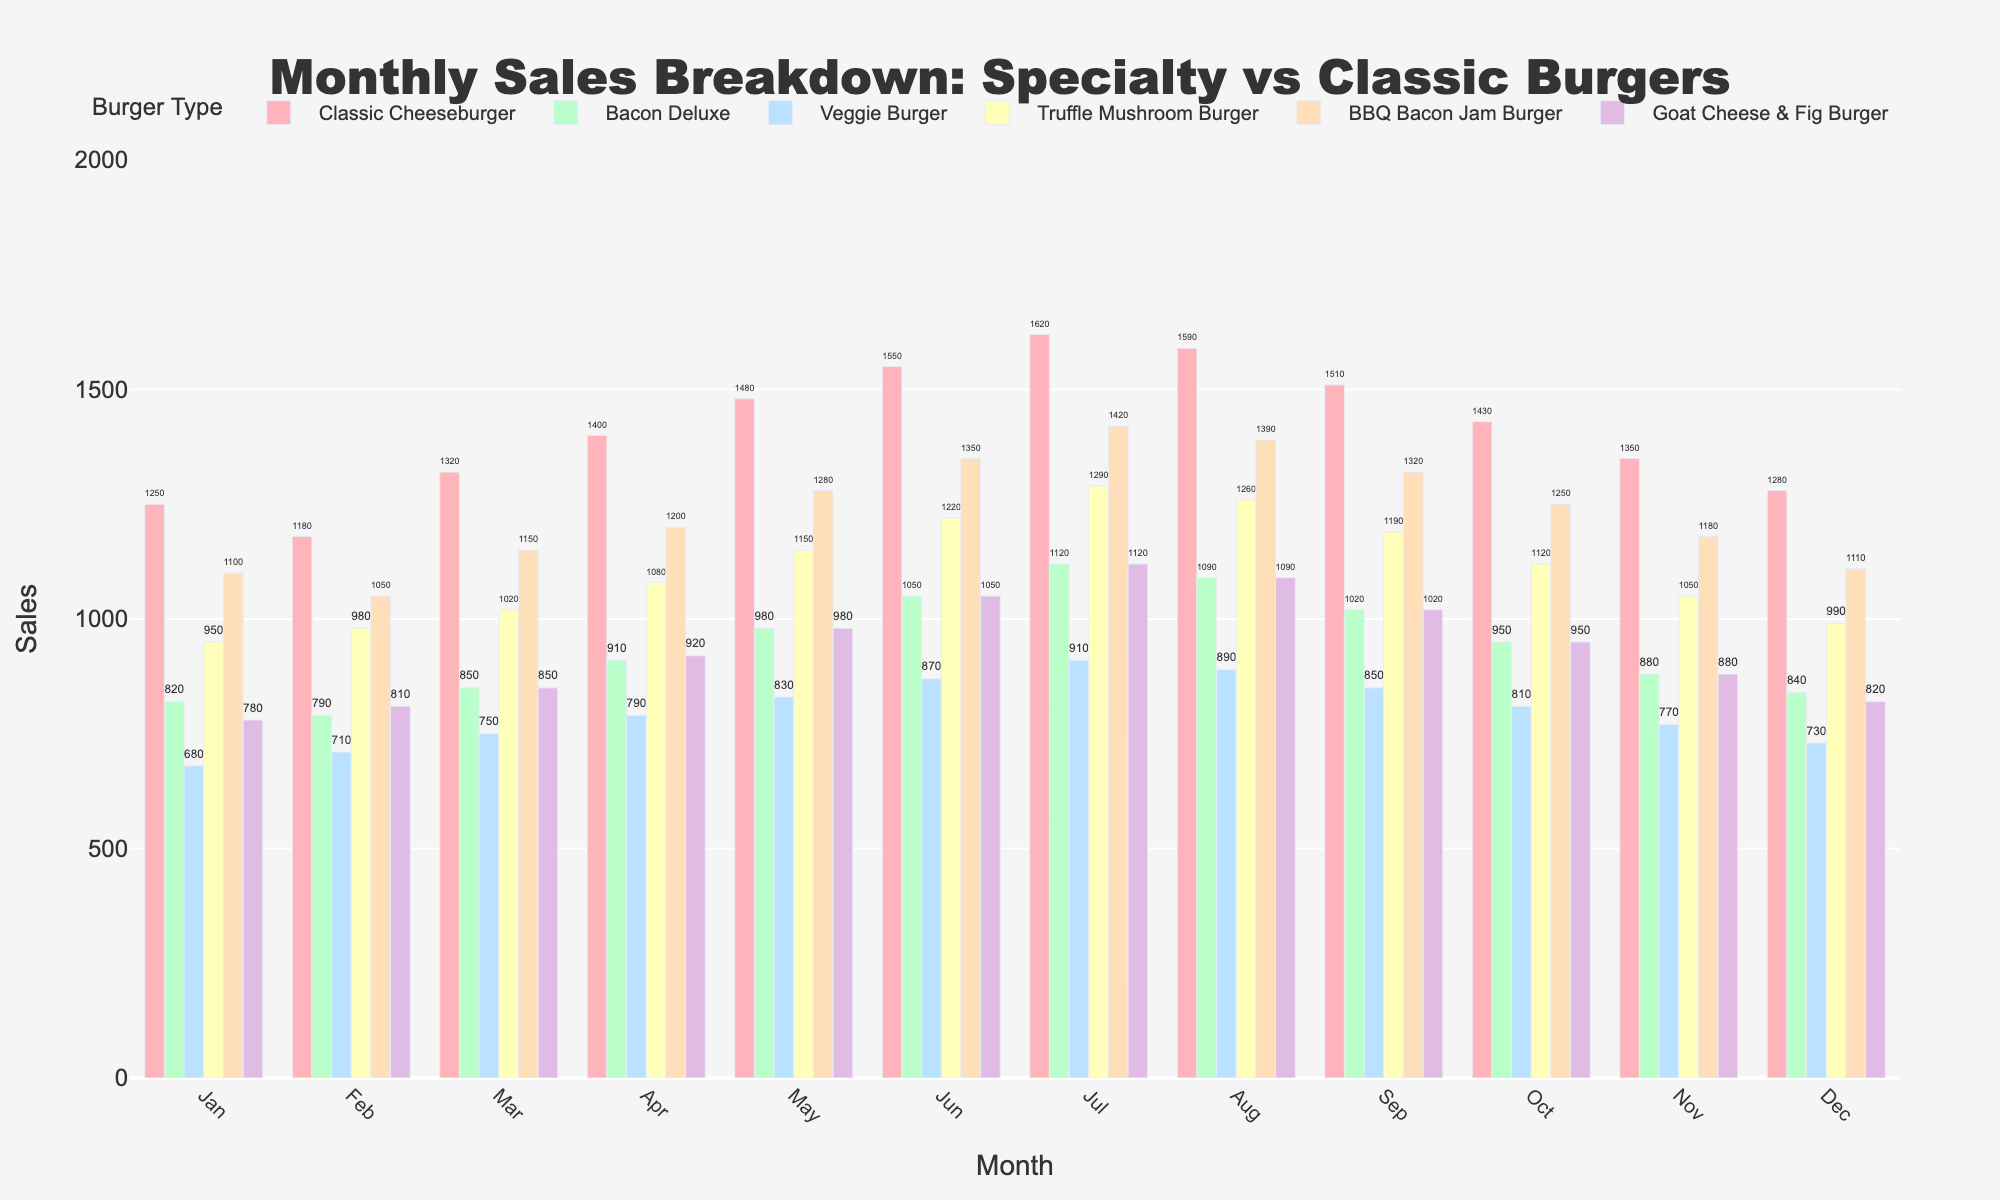What's the total sales in June for all burger types? To find the total sales in June, sum up the sales numbers for all burger types in that month. Adding them: 1550 (Classic Cheeseburger) + 1050 (Bacon Deluxe) + 870 (Veggie Burger) + 1220 (Truffle Mushroom Burger) + 1350 (BBQ Bacon Jam Burger) + 1050 (Goat Cheese & Fig Burger) = 7090
Answer: 7090 Which month had the highest sales for the BBQ Bacon Jam Burger? To answer, look at the BBQ Bacon Jam Burger data across all months. August shows the peak with a value of 1420.
Answer: August Is the sales trend for the Classic Cheeseburger increasing or decreasing over the year? By observing the heights of the bars for Classic Cheeseburger across months from January to December, their increasing height indicates that the sales trend is generally increasing.
Answer: Increasing In which month did the Goat Cheese & Fig Burger have its highest sales, and what was the value? Check the sales values for Goat Cheese & Fig Burger for each month, the highest value is in July with sales of 1120.
Answer: July, 1120 What is the difference in sales between the highest and lowest month for the Veggie Burger? Identify the highest and lowest sales for Veggie Burger: the highest is July (910) and the lowest is January (680). The difference is 910 - 680 = 230.
Answer: 230 Which specialty burger had the most consistent sales numbers over the months? Check the variability in sales for each specialty burger (Bacon Deluxe, Veggie Burger, Truffle Mushroom Burger, BBQ Bacon Jam Burger, Goat Cheese & Fig Burger). The Bacon Deluxe shows less variation and seems the most consistent.
Answer: Bacon Deluxe Compare the average monthly sales of the Bacon Deluxe and the Truffle Mushroom Burger. Which one is higher? Calculate the average sales for both: Bacon Deluxe (sum: 10500, average: 875), Truffle Mushroom Burger (sum: 13500, average: 1125). The Truffle Mushroom Burger has a higher average monthly sales.
Answer: Truffle Mushroom Burger How did the November sales for the Veggie Burger compare to its sales in the preceding month? Check the sales of the Veggie Burger for October (810) and November (770). The sales in November are lower by 40 units (810 - 770 = 40).
Answer: Lower by 40 units What's the combined sales of all specialty burgers (excluding Classic Cheeseburger) in March? Sum the sales for Bacon Deluxe, Veggie Burger, Truffle Mushroom Burger, BBQ Bacon Jam Burger, and Goat Cheese & Fig Burger in March: 850 + 750 + 1020 + 1150 + 850 = 4620.
Answer: 4620 